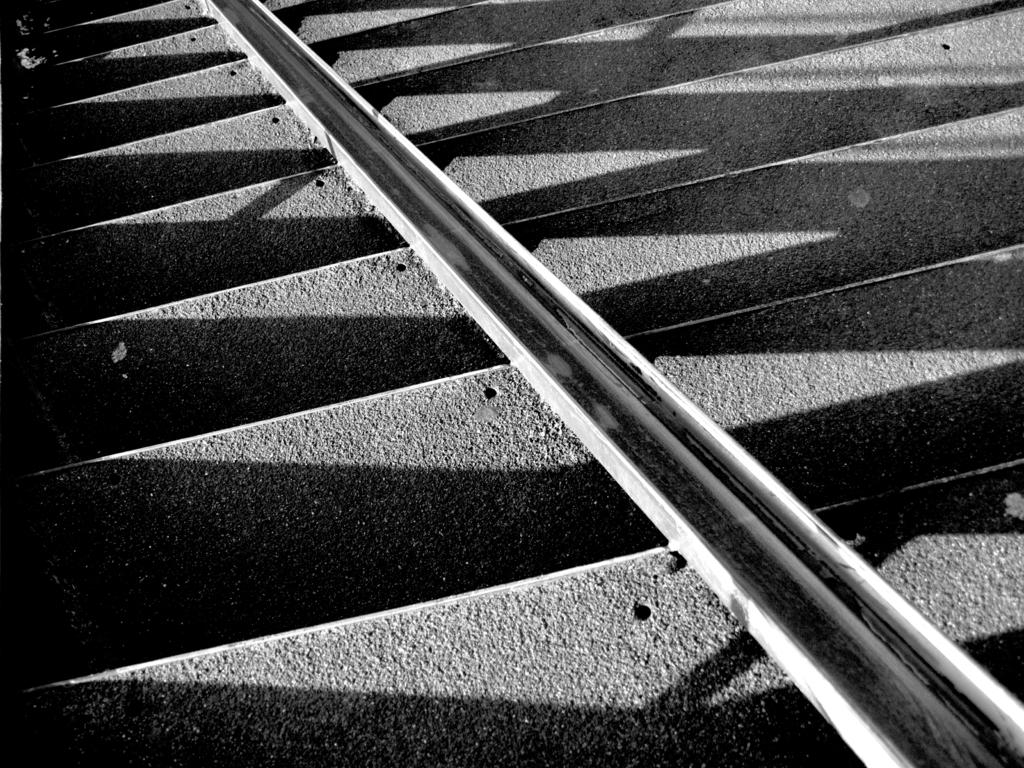What is the color scheme of the image? The image is black and white. What object can be seen on the steps in the image? There is a metal pole on the steps in the image. What can be observed on the steps besides the metal pole? Shadows are visible on the steps. Can you see the moon in the image? No, the moon is not present in the image. Is there a snail crawling on the metal pole in the image? No, there is no snail visible in the image. 